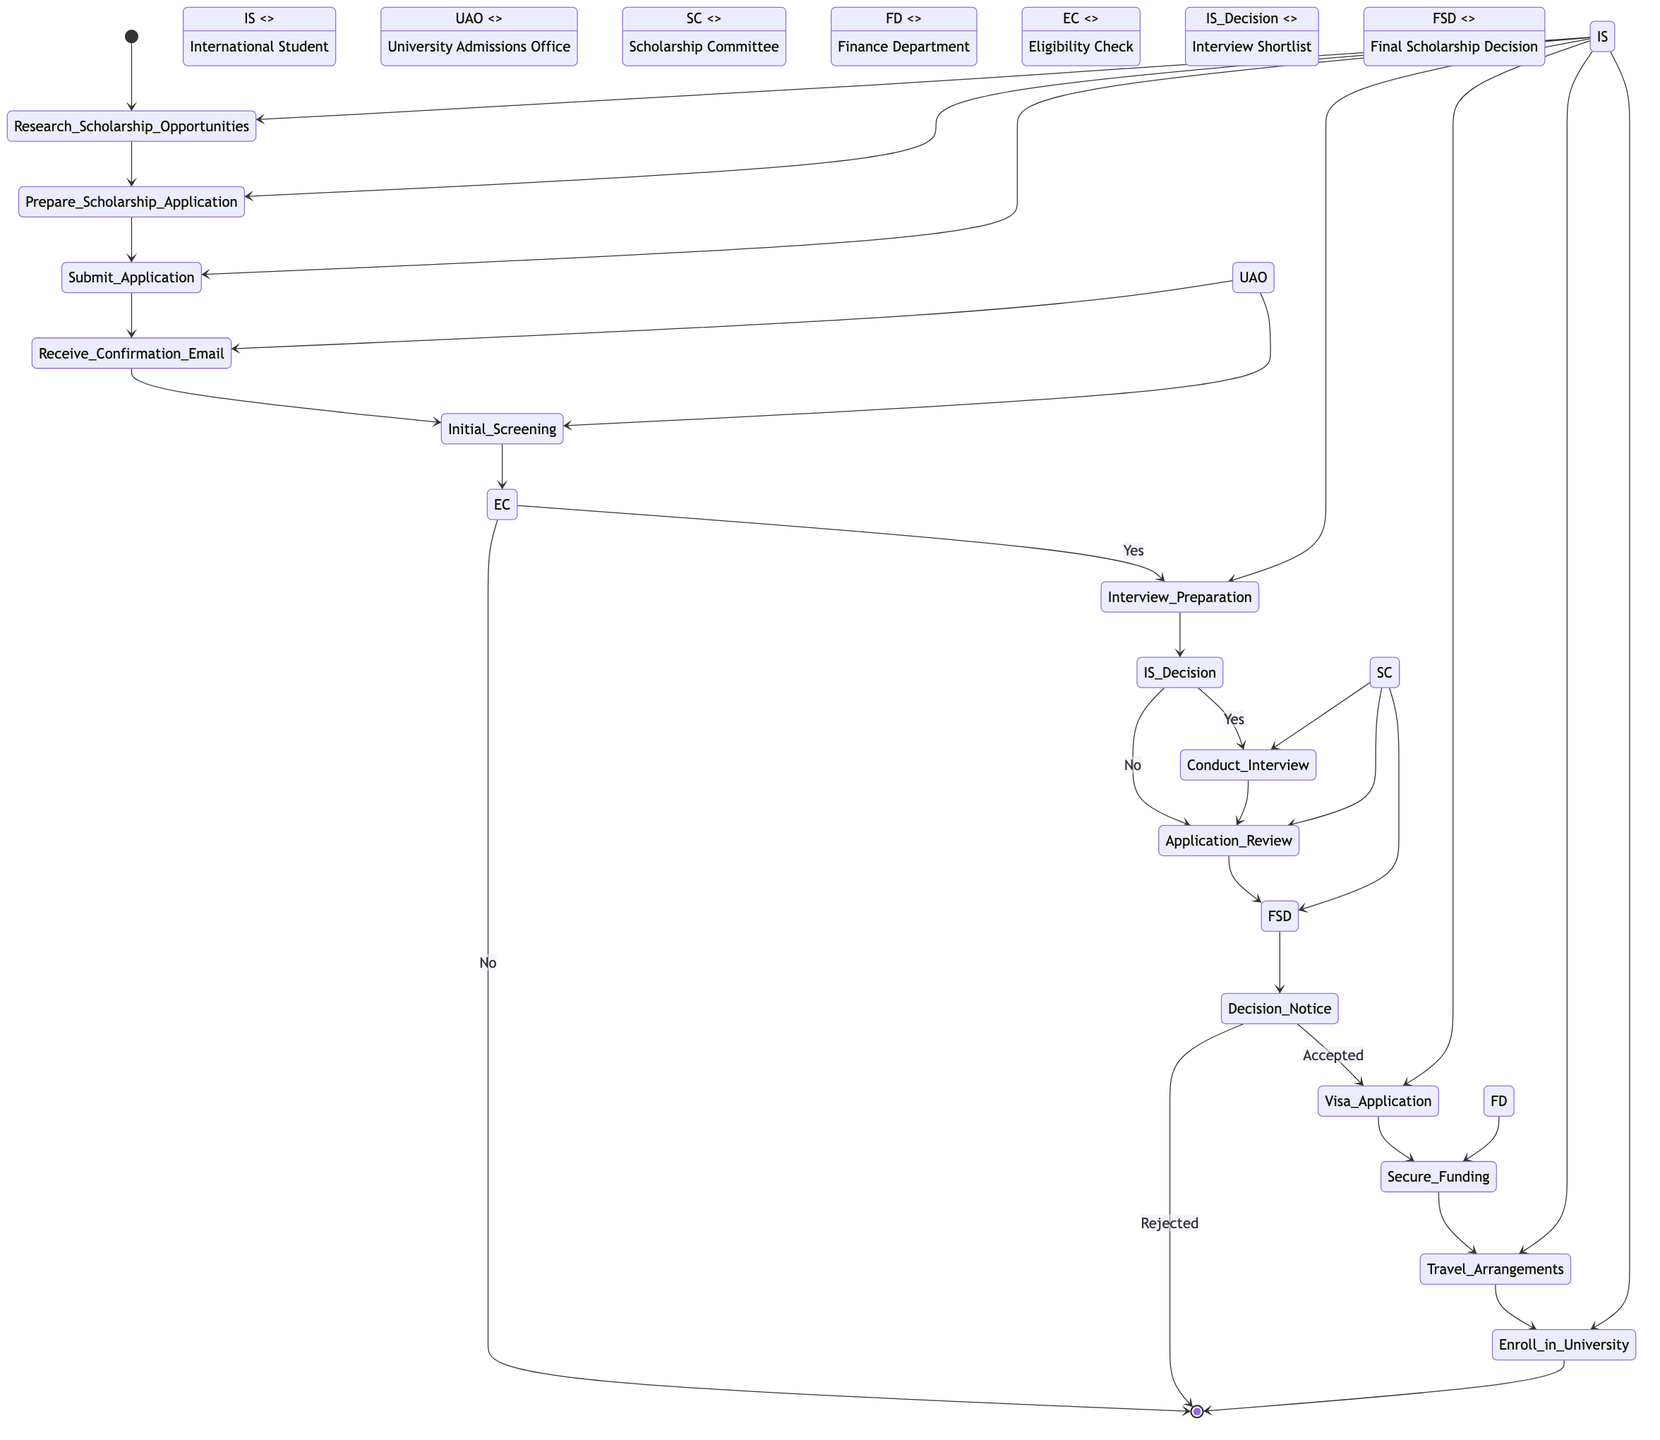What is the starting point of the activity diagram? The starting point, indicated in the diagram, is marked as "Start".
Answer: Start How many actors are involved in the process? By counting the listed actors in the diagram, we see there are six actors: International Student, University Admissions Office, Embassy/Consulate, Scholarship Committee, Academic Advisor, and Finance Department.
Answer: 6 What activity follows "Receive Confirmation Email"? The activity that takes place immediately after "Receive Confirmation Email" is "Initial Screening".
Answer: Initial Screening What decision occurs after "Initial Screening"? After "Initial Screening," there is a decision node called "Eligibility Check."
Answer: Eligibility Check What is the last activity before the diagram ends? The last activity before reaching the end of the diagram is "Enroll in University."
Answer: Enroll in University How many decisions are there in the flow? There are three decision nodes in the flow: Eligibility Check, Interview Shortlist, and Final Scholarship Decision.
Answer: 3 Which actor is involved in the "Secure Funding" activity? The actor involved in the "Secure Funding" activity is the Finance Department.
Answer: Finance Department What happens if the student's application is rejected after the "Decision Notice"? If the student's application is rejected after the "Decision Notice," it leads back to the end of the diagram.
Answer: End What activity is linked to "Decision Notice" if accepted? If accepted, the activity linked to "Decision Notice" is "Visa Application."
Answer: Visa Application 